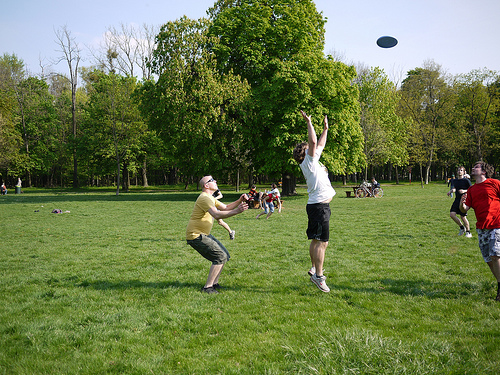Is the man to the right of the bench wearing a suit? No, the man to the right of the bench is not wearing a suit; he is dressed in casual attire. 